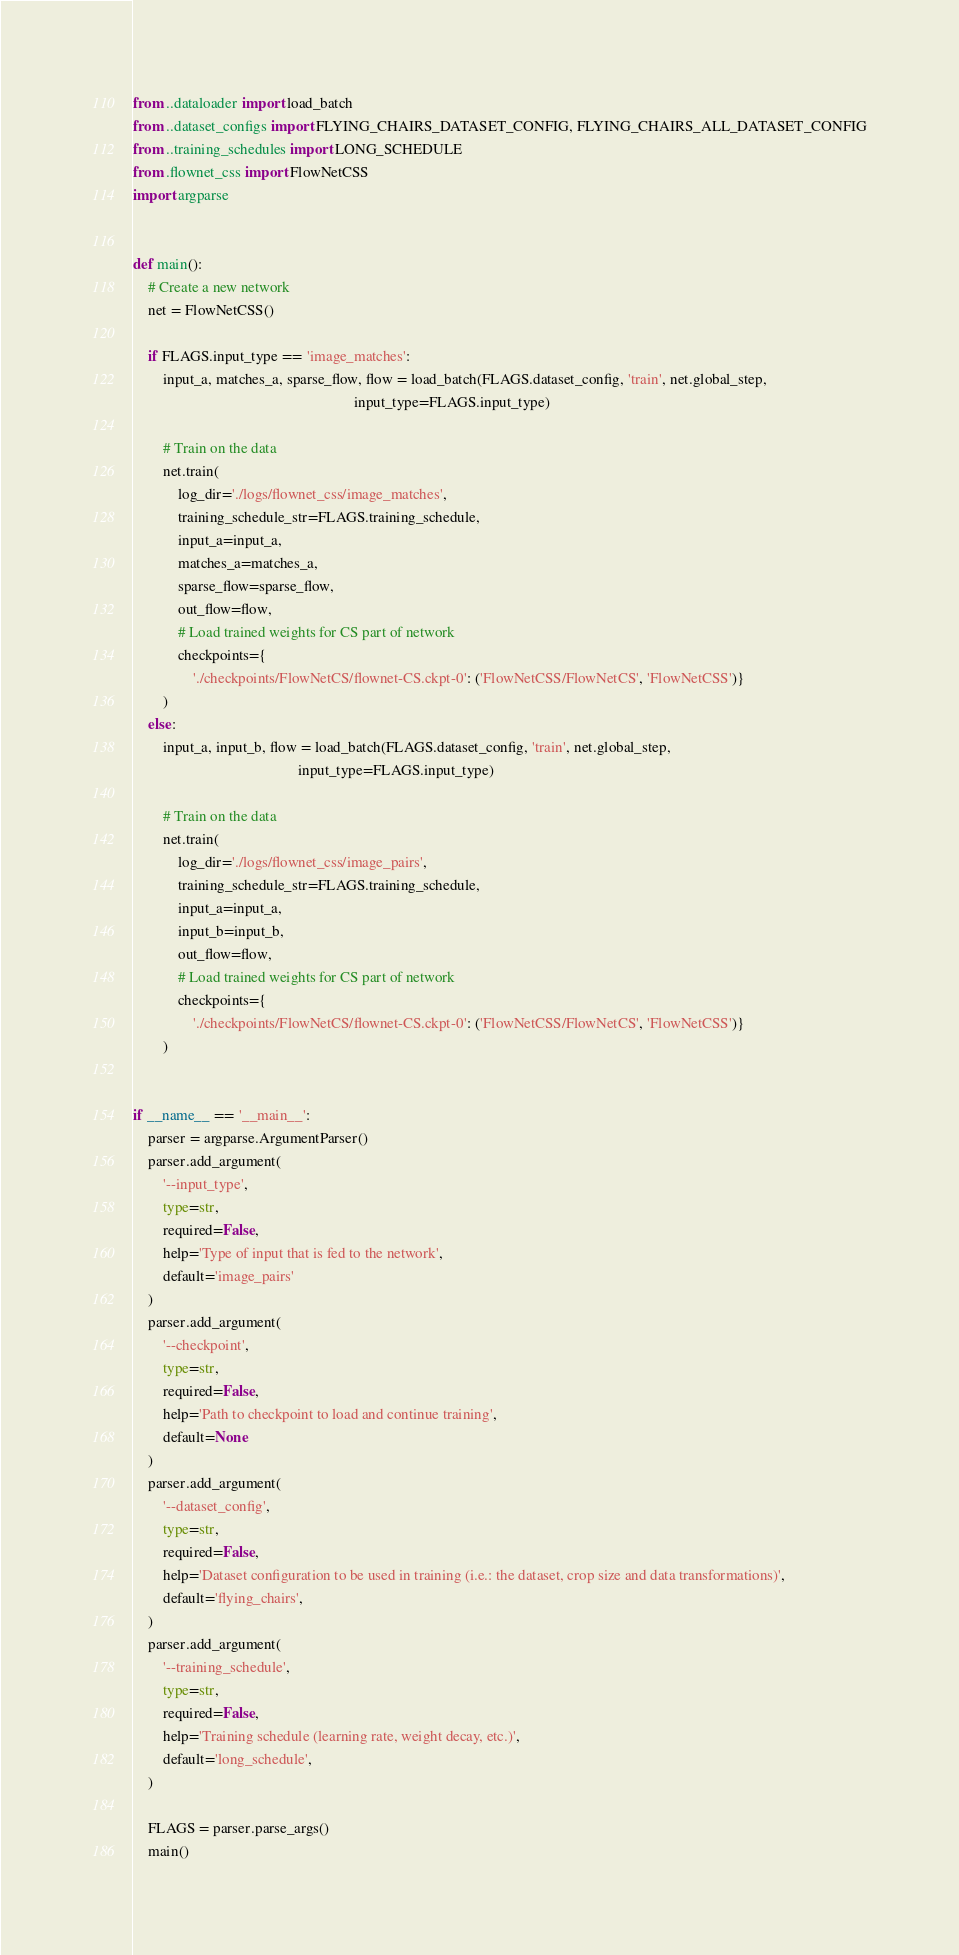<code> <loc_0><loc_0><loc_500><loc_500><_Python_>from ..dataloader import load_batch
from ..dataset_configs import FLYING_CHAIRS_DATASET_CONFIG, FLYING_CHAIRS_ALL_DATASET_CONFIG
from ..training_schedules import LONG_SCHEDULE
from .flownet_css import FlowNetCSS
import argparse


def main():
    # Create a new network
    net = FlowNetCSS()

    if FLAGS.input_type == 'image_matches':
        input_a, matches_a, sparse_flow, flow = load_batch(FLAGS.dataset_config, 'train', net.global_step,
                                                           input_type=FLAGS.input_type)

        # Train on the data
        net.train(
            log_dir='./logs/flownet_css/image_matches',
            training_schedule_str=FLAGS.training_schedule,
            input_a=input_a,
            matches_a=matches_a,
            sparse_flow=sparse_flow,
            out_flow=flow,
            # Load trained weights for CS part of network
            checkpoints={
                './checkpoints/FlowNetCS/flownet-CS.ckpt-0': ('FlowNetCSS/FlowNetCS', 'FlowNetCSS')}
        )
    else:
        input_a, input_b, flow = load_batch(FLAGS.dataset_config, 'train', net.global_step,
                                            input_type=FLAGS.input_type)

        # Train on the data
        net.train(
            log_dir='./logs/flownet_css/image_pairs',
            training_schedule_str=FLAGS.training_schedule,
            input_a=input_a,
            input_b=input_b,
            out_flow=flow,
            # Load trained weights for CS part of network
            checkpoints={
                './checkpoints/FlowNetCS/flownet-CS.ckpt-0': ('FlowNetCSS/FlowNetCS', 'FlowNetCSS')}
        )


if __name__ == '__main__':
    parser = argparse.ArgumentParser()
    parser.add_argument(
        '--input_type',
        type=str,
        required=False,
        help='Type of input that is fed to the network',
        default='image_pairs'
    )
    parser.add_argument(
        '--checkpoint',
        type=str,
        required=False,
        help='Path to checkpoint to load and continue training',
        default=None
    )
    parser.add_argument(
        '--dataset_config',
        type=str,
        required=False,
        help='Dataset configuration to be used in training (i.e.: the dataset, crop size and data transformations)',
        default='flying_chairs',
    )
    parser.add_argument(
        '--training_schedule',
        type=str,
        required=False,
        help='Training schedule (learning rate, weight decay, etc.)',
        default='long_schedule',
    )

    FLAGS = parser.parse_args()
    main()
</code> 